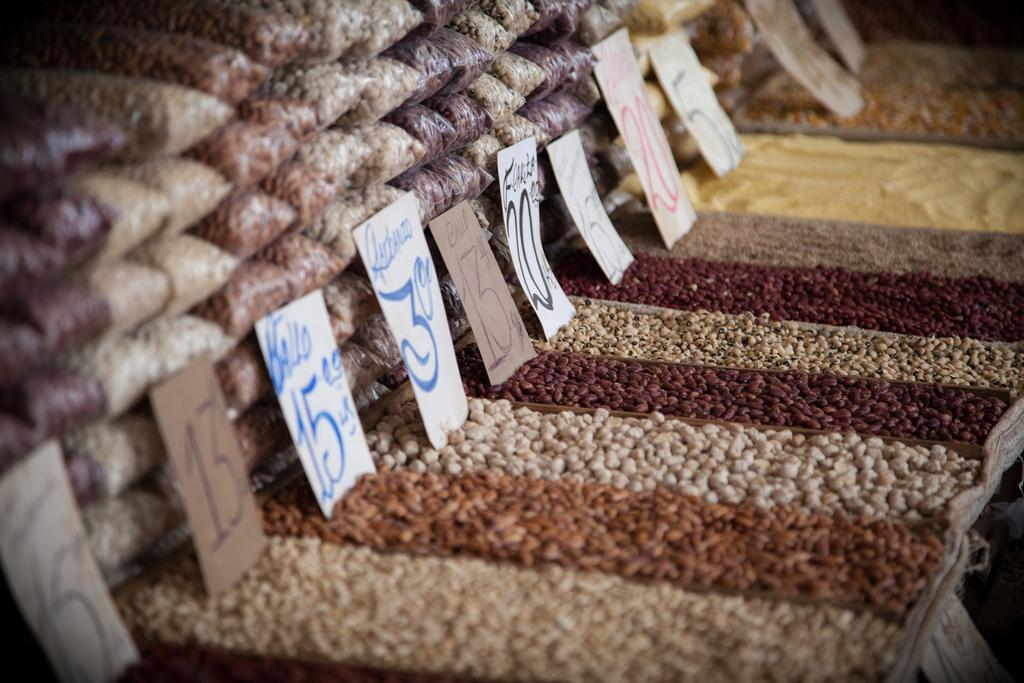What type of material is visible in the image? There are grains in the image. How are the grains being stored or contained? The grains are packed with covers. What additional objects can be seen in the image? There are name boards in the image. What type of action is the nest performing in the image? There is no nest present in the image. How is the hook being used in the image? There is no hook present in the image. 